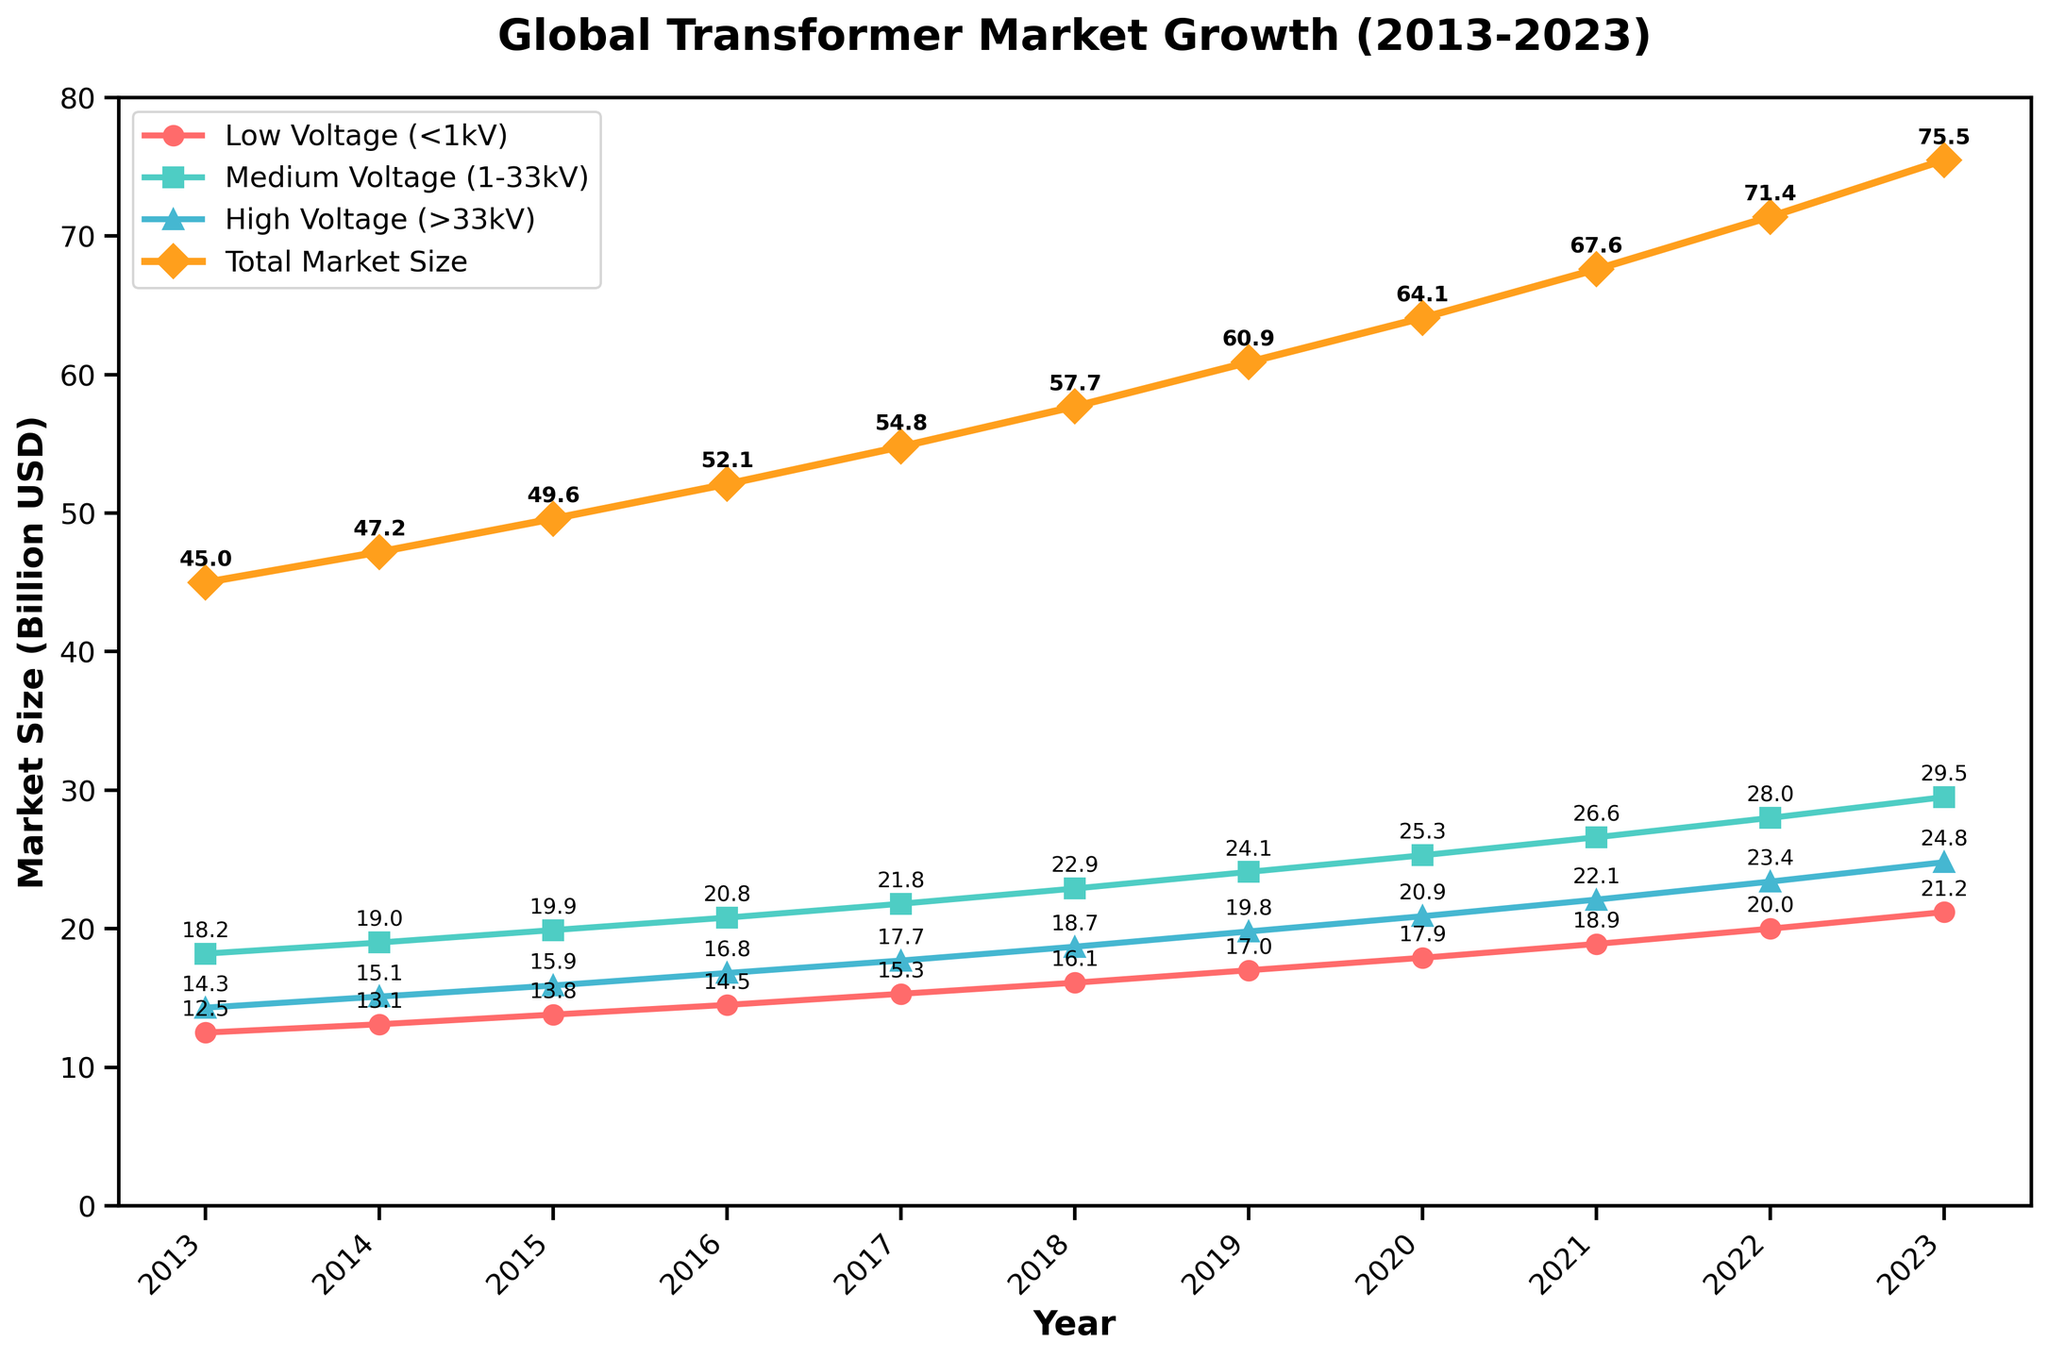What is the total market size for 2019? Identify the point corresponding to the year 2019 on the "Total Market Size" line plot. The value annotated is 60.9 Billion USD.
Answer: 60.9 Billion USD How did the market for low voltage transformers change from 2013 to 2023? Examine the values for low voltage transformers in 2013 and 2023. In 2013, it was 12.5 Billion USD, and in 2023, it is 21.2 Billion USD. Calculate the difference to see the change: 21.2 - 12.5 = 8.7 Billion USD.
Answer: Increased by 8.7 Billion USD Which voltage rating had the highest market size in 2020? Refer to the data points for 2020 for all voltage ratings: Low Voltage (17.9), Medium Voltage (25.3), High Voltage (20.9). The highest value is 25.3 Billion USD for Medium Voltage.
Answer: Medium Voltage Comparing 2018 and 2022, by how much did the total market size grow? Look at the total market size for 2018 (57.7 Billion USD) and 2022 (71.4 Billion USD). The growth is 71.4 - 57.7 = 13.7 Billion USD.
Answer: Grew by 13.7 Billion USD What was the average market size for medium voltage transformers over the decade? Sum the market sizes for medium voltage from 2013 to 2023 and divide by the number of years: (18.2 + 19.0 + 19.9 + 20.8 + 21.8 + 22.9 + 24.1 + 25.3 + 26.6 + 28.0 + 29.5) / 11 = 22.7 Billion USD.
Answer: 22.7 Billion USD By what percentage did the medium voltage market size increase from 2017 to 2023? Use the formula for percentage increase: ((New Value - Old Value) / Old Value) x 100. For 2017 to 2023: ((29.5 - 21.8) / 21.8) x 100 ≈ 35.3%.
Answer: Approximately 35.3% What is the trend of the total market size over the decade? Observe the "Total Market Size" line trend from 2013 to 2023. The line consistently rises, indicating a steady upward trend.
Answer: Steady upward trend 